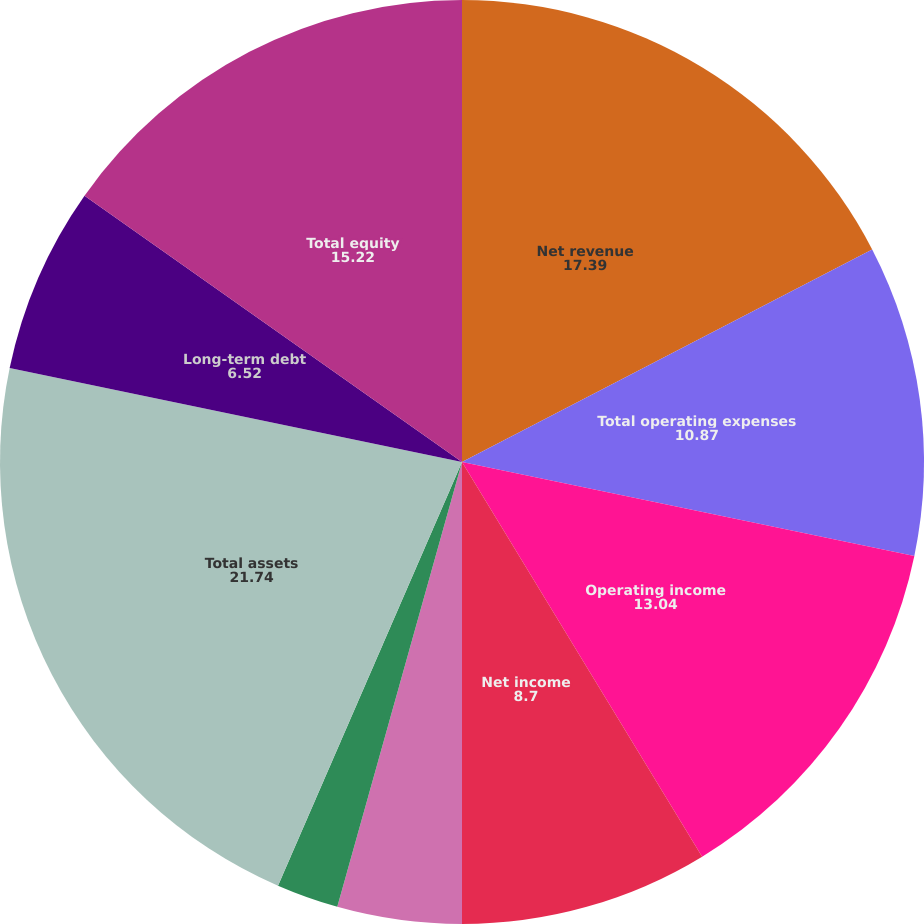<chart> <loc_0><loc_0><loc_500><loc_500><pie_chart><fcel>Net revenue<fcel>Total operating expenses<fcel>Operating income<fcel>Net income<fcel>Basic earnings per share<fcel>Diluted earnings per share<fcel>Total assets<fcel>Long-term debt<fcel>Total equity<fcel>Cash dividends declared per<nl><fcel>17.39%<fcel>10.87%<fcel>13.04%<fcel>8.7%<fcel>4.35%<fcel>2.17%<fcel>21.74%<fcel>6.52%<fcel>15.22%<fcel>0.0%<nl></chart> 